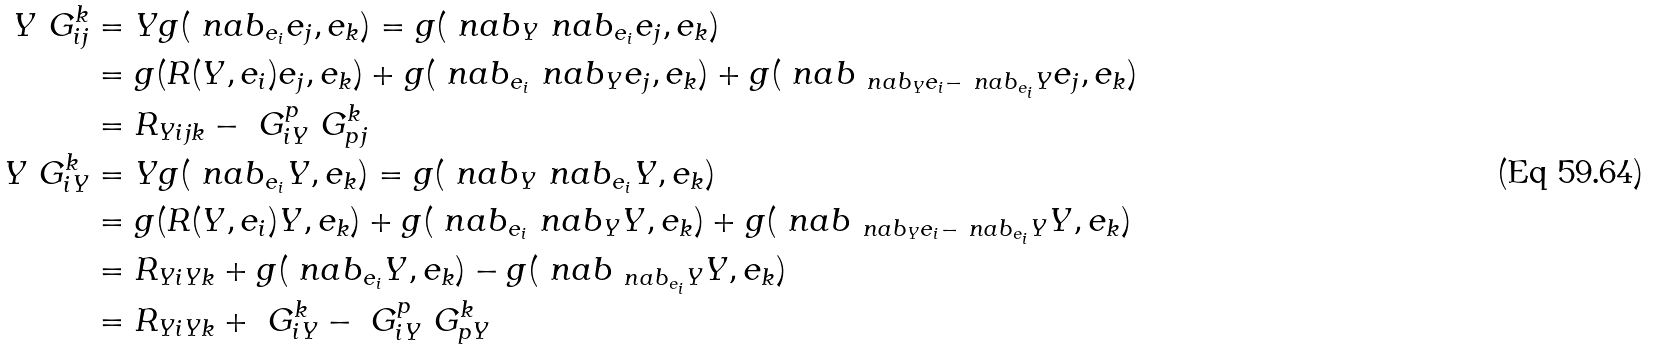Convert formula to latex. <formula><loc_0><loc_0><loc_500><loc_500>Y \ G _ { i j } ^ { k } & = Y g ( \ n a b _ { e _ { i } } e _ { j } , e _ { k } ) = g ( \ n a b _ { Y } \ n a b _ { e _ { i } } e _ { j } , e _ { k } ) \\ & = g ( R ( Y , e _ { i } ) e _ { j } , e _ { k } ) + g ( \ n a b _ { e _ { i } } \ n a b _ { Y } e _ { j } , e _ { k } ) + g ( \ n a b _ { \ n a b _ { Y } { e _ { i } } - \ n a b _ { e _ { i } } Y } e _ { j } , e _ { k } ) \\ & = R _ { Y i j k } - \ G _ { i Y } ^ { p } \ G _ { p j } ^ { k } \\ Y \ G _ { i Y } ^ { k } & = Y g ( \ n a b _ { e _ { i } } Y , e _ { k } ) = g ( \ n a b _ { Y } \ n a b _ { e _ { i } } Y , e _ { k } ) \\ & = g ( R ( Y , e _ { i } ) Y , e _ { k } ) + g ( \ n a b _ { e _ { i } } \ n a b _ { Y } Y , e _ { k } ) + g ( \ n a b _ { \ n a b _ { Y } { e _ { i } } - \ n a b _ { e _ { i } } Y } Y , e _ { k } ) \\ & = R _ { Y i Y k } + g ( \ n a b _ { e _ { i } } Y , e _ { k } ) - g ( \ n a b _ { \ n a b _ { e _ { i } } Y } Y , e _ { k } ) \\ & = R _ { Y i Y k } + \ G _ { i Y } ^ { k } - \ G _ { i Y } ^ { p } \ G _ { p Y } ^ { k }</formula> 